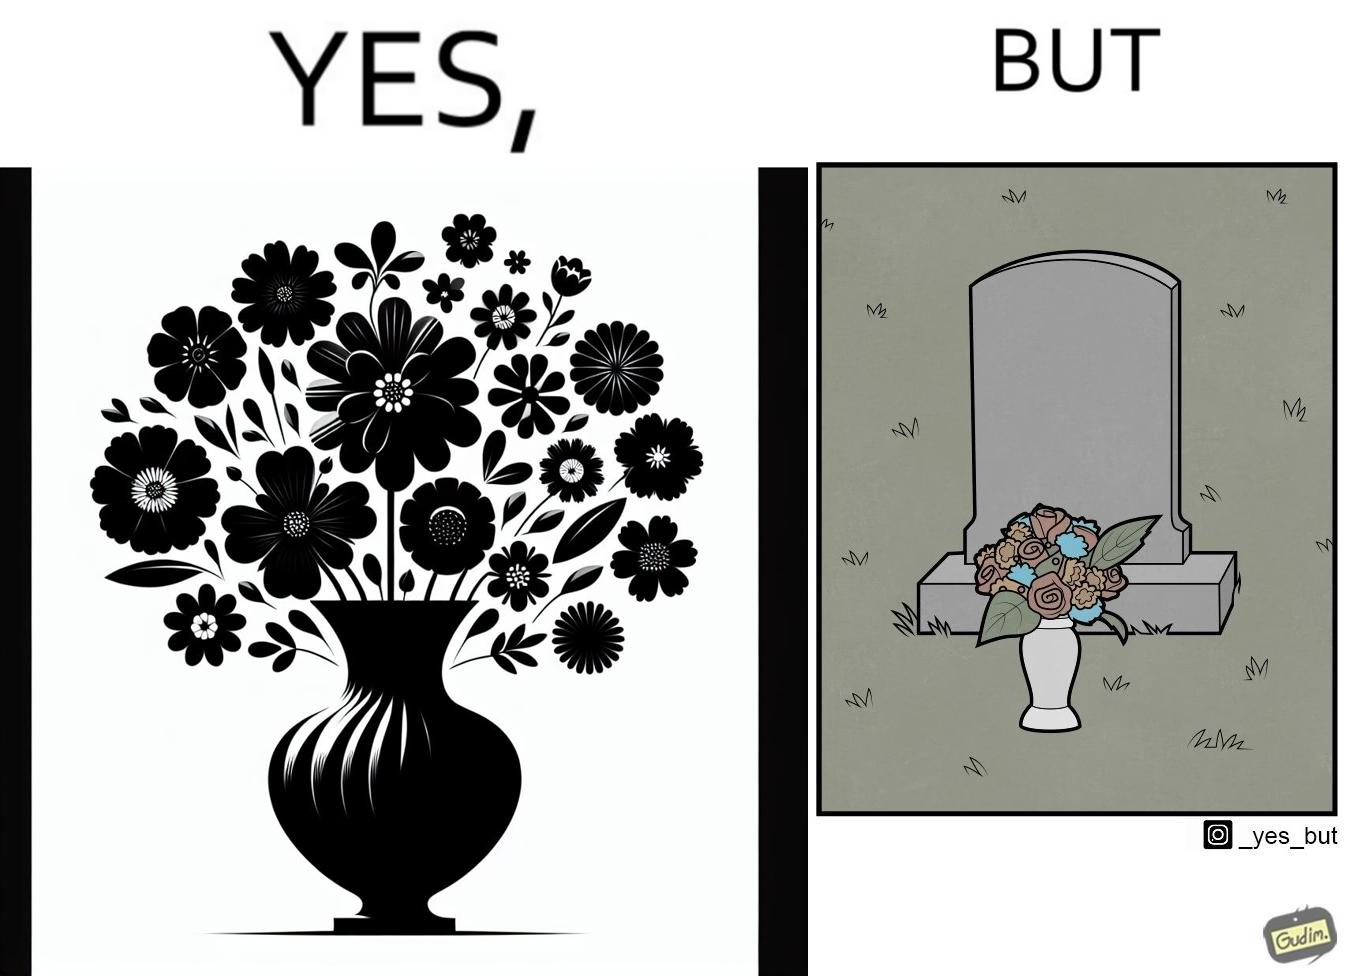What do you see in each half of this image? In the left part of the image: a beautiful vase of full of different beautiful flowers In the right part of the image: a beautiful vase of full of different beautiful flowers put in front of someone's grave stone 